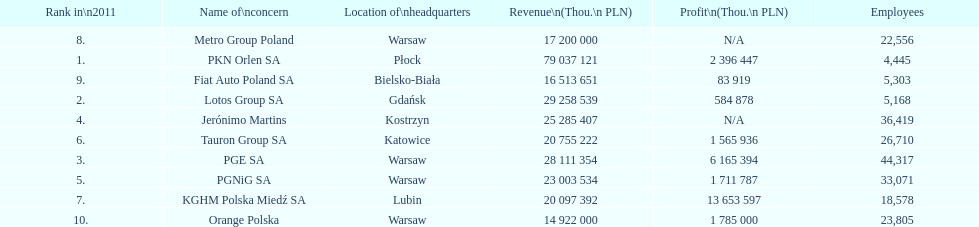What is the number of employees who work for pgnig sa? 33,071. Parse the table in full. {'header': ['Rank in\\n2011', 'Name of\\nconcern', 'Location of\\nheadquarters', 'Revenue\\n(Thou.\\n\xa0PLN)', 'Profit\\n(Thou.\\n\xa0PLN)', 'Employees'], 'rows': [['8.', 'Metro Group Poland', 'Warsaw', '17 200 000', 'N/A', '22,556'], ['1.', 'PKN Orlen SA', 'Płock', '79 037 121', '2 396 447', '4,445'], ['9.', 'Fiat Auto Poland SA', 'Bielsko-Biała', '16 513 651', '83 919', '5,303'], ['2.', 'Lotos Group SA', 'Gdańsk', '29 258 539', '584 878', '5,168'], ['4.', 'Jerónimo Martins', 'Kostrzyn', '25 285 407', 'N/A', '36,419'], ['6.', 'Tauron Group SA', 'Katowice', '20 755 222', '1 565 936', '26,710'], ['3.', 'PGE SA', 'Warsaw', '28 111 354', '6 165 394', '44,317'], ['5.', 'PGNiG SA', 'Warsaw', '23 003 534', '1 711 787', '33,071'], ['7.', 'KGHM Polska Miedź SA', 'Lubin', '20 097 392', '13 653 597', '18,578'], ['10.', 'Orange Polska', 'Warsaw', '14 922 000', '1 785 000', '23,805']]} 